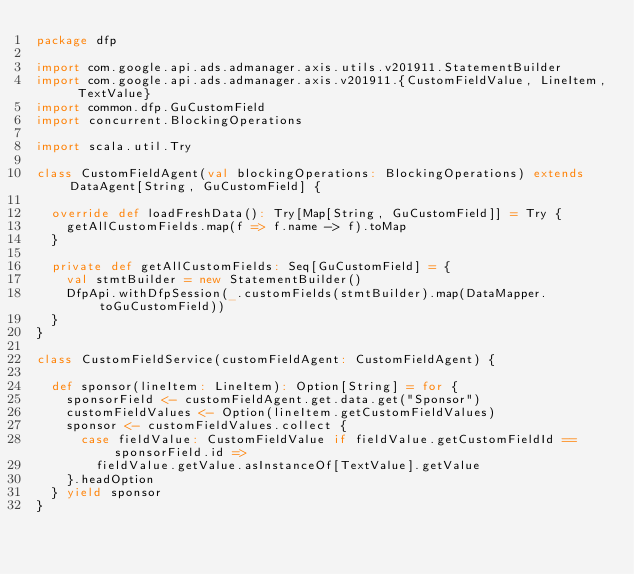Convert code to text. <code><loc_0><loc_0><loc_500><loc_500><_Scala_>package dfp

import com.google.api.ads.admanager.axis.utils.v201911.StatementBuilder
import com.google.api.ads.admanager.axis.v201911.{CustomFieldValue, LineItem, TextValue}
import common.dfp.GuCustomField
import concurrent.BlockingOperations

import scala.util.Try

class CustomFieldAgent(val blockingOperations: BlockingOperations) extends DataAgent[String, GuCustomField] {

  override def loadFreshData(): Try[Map[String, GuCustomField]] = Try {
    getAllCustomFields.map(f => f.name -> f).toMap
  }

  private def getAllCustomFields: Seq[GuCustomField] = {
    val stmtBuilder = new StatementBuilder()
    DfpApi.withDfpSession(_.customFields(stmtBuilder).map(DataMapper.toGuCustomField))
  }
}

class CustomFieldService(customFieldAgent: CustomFieldAgent) {

  def sponsor(lineItem: LineItem): Option[String] = for {
    sponsorField <- customFieldAgent.get.data.get("Sponsor")
    customFieldValues <- Option(lineItem.getCustomFieldValues)
    sponsor <- customFieldValues.collect {
      case fieldValue: CustomFieldValue if fieldValue.getCustomFieldId == sponsorField.id =>
        fieldValue.getValue.asInstanceOf[TextValue].getValue
    }.headOption
  } yield sponsor
}
</code> 